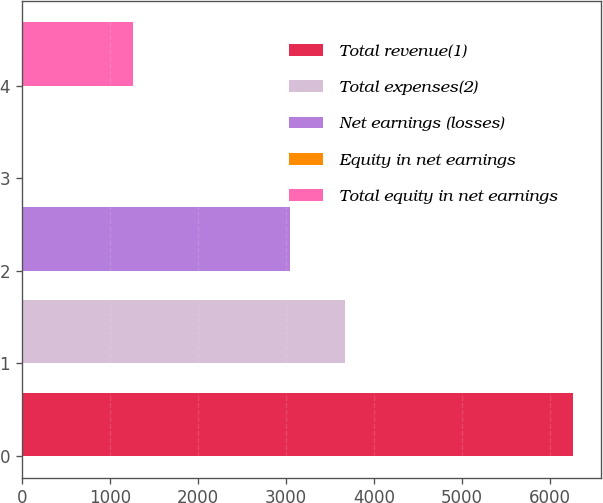<chart> <loc_0><loc_0><loc_500><loc_500><bar_chart><fcel>Total revenue(1)<fcel>Total expenses(2)<fcel>Net earnings (losses)<fcel>Equity in net earnings<fcel>Total equity in net earnings<nl><fcel>6264<fcel>3667<fcel>3042<fcel>14<fcel>1264<nl></chart> 